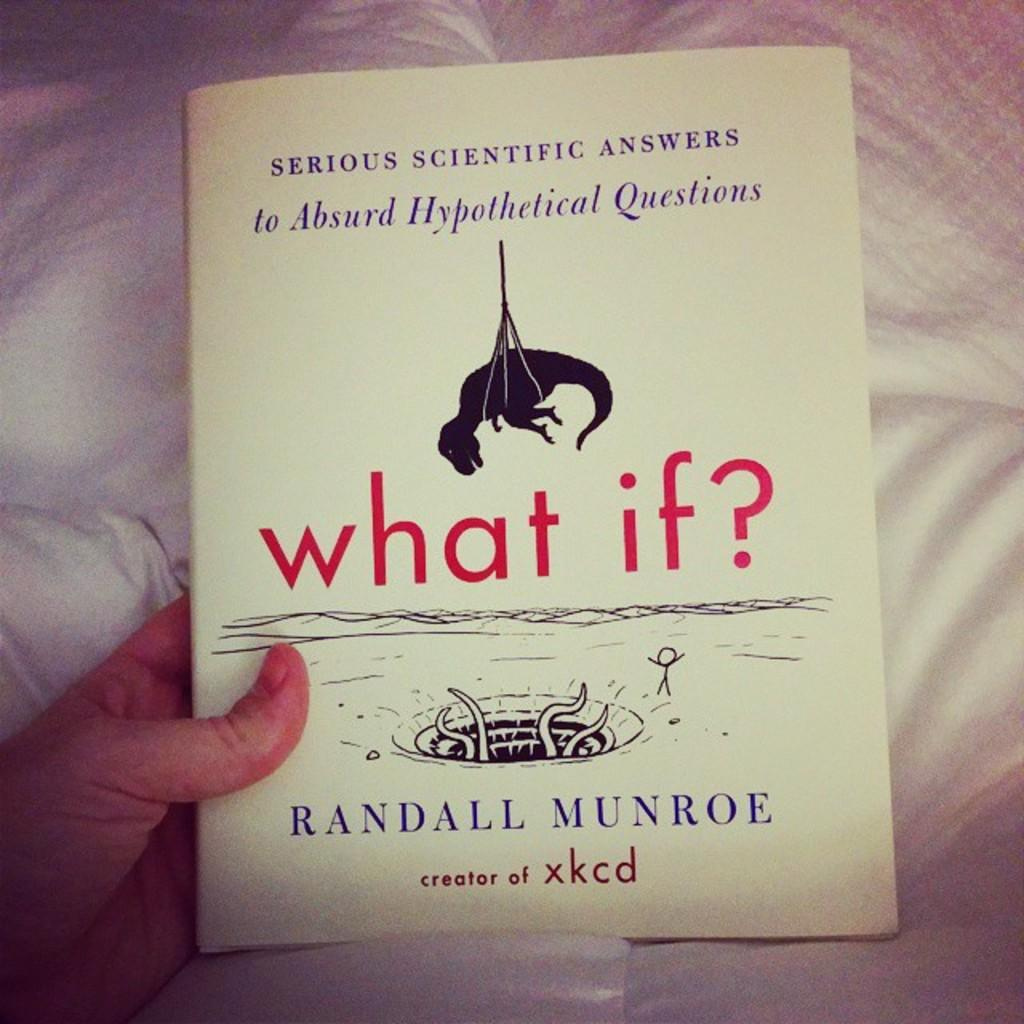<image>
Give a short and clear explanation of the subsequent image. A person holding a box by Randall Munroe, creator of xkcd. 